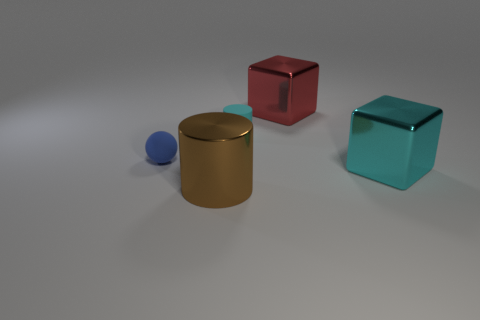Add 3 cyan cylinders. How many objects exist? 8 Subtract all balls. How many objects are left? 4 Subtract 1 cyan cylinders. How many objects are left? 4 Subtract all large purple balls. Subtract all brown things. How many objects are left? 4 Add 1 brown metal objects. How many brown metal objects are left? 2 Add 5 red shiny blocks. How many red shiny blocks exist? 6 